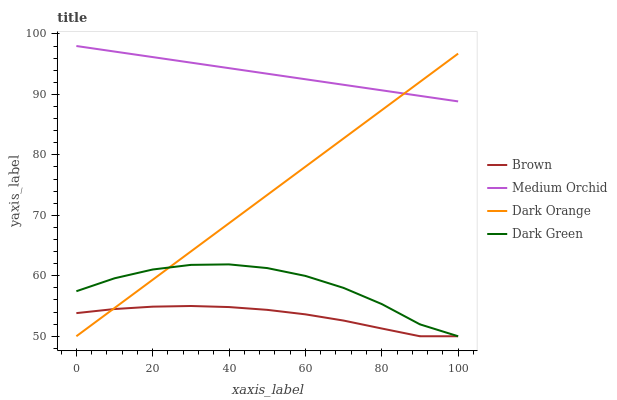Does Dark Green have the minimum area under the curve?
Answer yes or no. No. Does Dark Green have the maximum area under the curve?
Answer yes or no. No. Is Dark Green the smoothest?
Answer yes or no. No. Is Medium Orchid the roughest?
Answer yes or no. No. Does Medium Orchid have the lowest value?
Answer yes or no. No. Does Dark Green have the highest value?
Answer yes or no. No. Is Brown less than Medium Orchid?
Answer yes or no. Yes. Is Medium Orchid greater than Brown?
Answer yes or no. Yes. Does Brown intersect Medium Orchid?
Answer yes or no. No. 